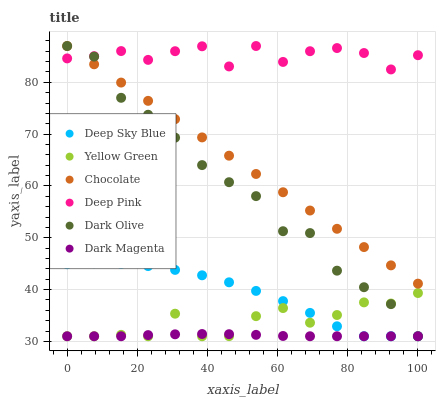Does Dark Magenta have the minimum area under the curve?
Answer yes or no. Yes. Does Deep Pink have the maximum area under the curve?
Answer yes or no. Yes. Does Dark Olive have the minimum area under the curve?
Answer yes or no. No. Does Dark Olive have the maximum area under the curve?
Answer yes or no. No. Is Chocolate the smoothest?
Answer yes or no. Yes. Is Deep Pink the roughest?
Answer yes or no. Yes. Is Dark Magenta the smoothest?
Answer yes or no. No. Is Dark Magenta the roughest?
Answer yes or no. No. Does Dark Magenta have the lowest value?
Answer yes or no. Yes. Does Chocolate have the lowest value?
Answer yes or no. No. Does Chocolate have the highest value?
Answer yes or no. Yes. Does Dark Magenta have the highest value?
Answer yes or no. No. Is Yellow Green less than Chocolate?
Answer yes or no. Yes. Is Deep Pink greater than Deep Sky Blue?
Answer yes or no. Yes. Does Dark Magenta intersect Dark Olive?
Answer yes or no. Yes. Is Dark Magenta less than Dark Olive?
Answer yes or no. No. Is Dark Magenta greater than Dark Olive?
Answer yes or no. No. Does Yellow Green intersect Chocolate?
Answer yes or no. No. 